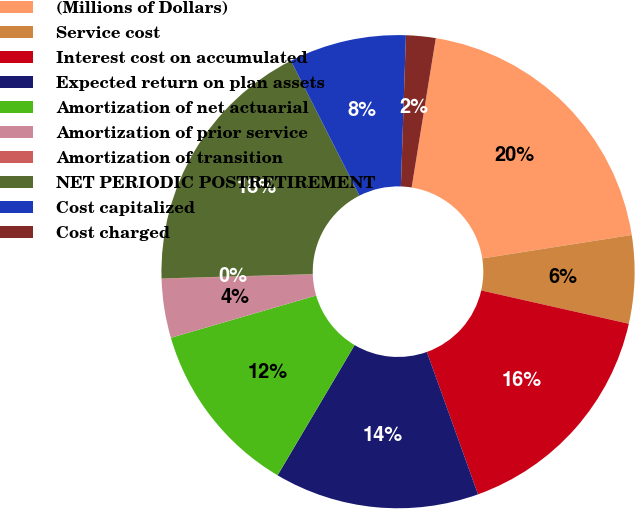Convert chart to OTSL. <chart><loc_0><loc_0><loc_500><loc_500><pie_chart><fcel>(Millions of Dollars)<fcel>Service cost<fcel>Interest cost on accumulated<fcel>Expected return on plan assets<fcel>Amortization of net actuarial<fcel>Amortization of prior service<fcel>Amortization of transition<fcel>NET PERIODIC POSTRETIREMENT<fcel>Cost capitalized<fcel>Cost charged<nl><fcel>19.97%<fcel>6.01%<fcel>15.98%<fcel>13.99%<fcel>11.99%<fcel>4.02%<fcel>0.03%<fcel>17.98%<fcel>8.01%<fcel>2.02%<nl></chart> 